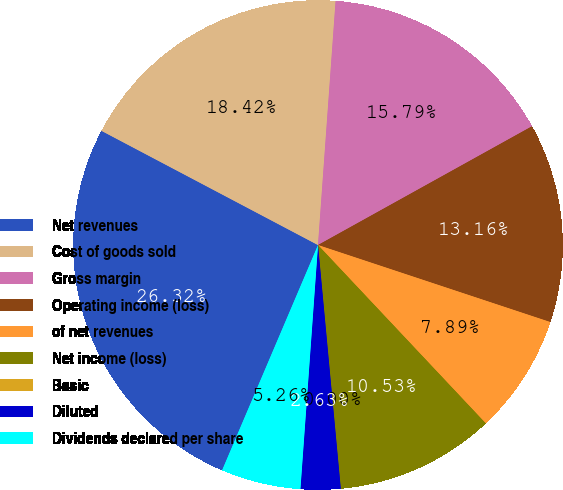<chart> <loc_0><loc_0><loc_500><loc_500><pie_chart><fcel>Net revenues<fcel>Cost of goods sold<fcel>Gross margin<fcel>Operating income (loss)<fcel>of net revenues<fcel>Net income (loss)<fcel>Basic<fcel>Diluted<fcel>Dividends declared per share<nl><fcel>26.32%<fcel>18.42%<fcel>15.79%<fcel>13.16%<fcel>7.89%<fcel>10.53%<fcel>0.0%<fcel>2.63%<fcel>5.26%<nl></chart> 